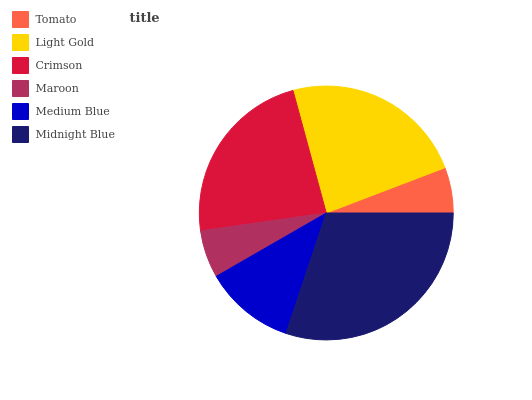Is Tomato the minimum?
Answer yes or no. Yes. Is Midnight Blue the maximum?
Answer yes or no. Yes. Is Light Gold the minimum?
Answer yes or no. No. Is Light Gold the maximum?
Answer yes or no. No. Is Light Gold greater than Tomato?
Answer yes or no. Yes. Is Tomato less than Light Gold?
Answer yes or no. Yes. Is Tomato greater than Light Gold?
Answer yes or no. No. Is Light Gold less than Tomato?
Answer yes or no. No. Is Crimson the high median?
Answer yes or no. Yes. Is Medium Blue the low median?
Answer yes or no. Yes. Is Maroon the high median?
Answer yes or no. No. Is Midnight Blue the low median?
Answer yes or no. No. 